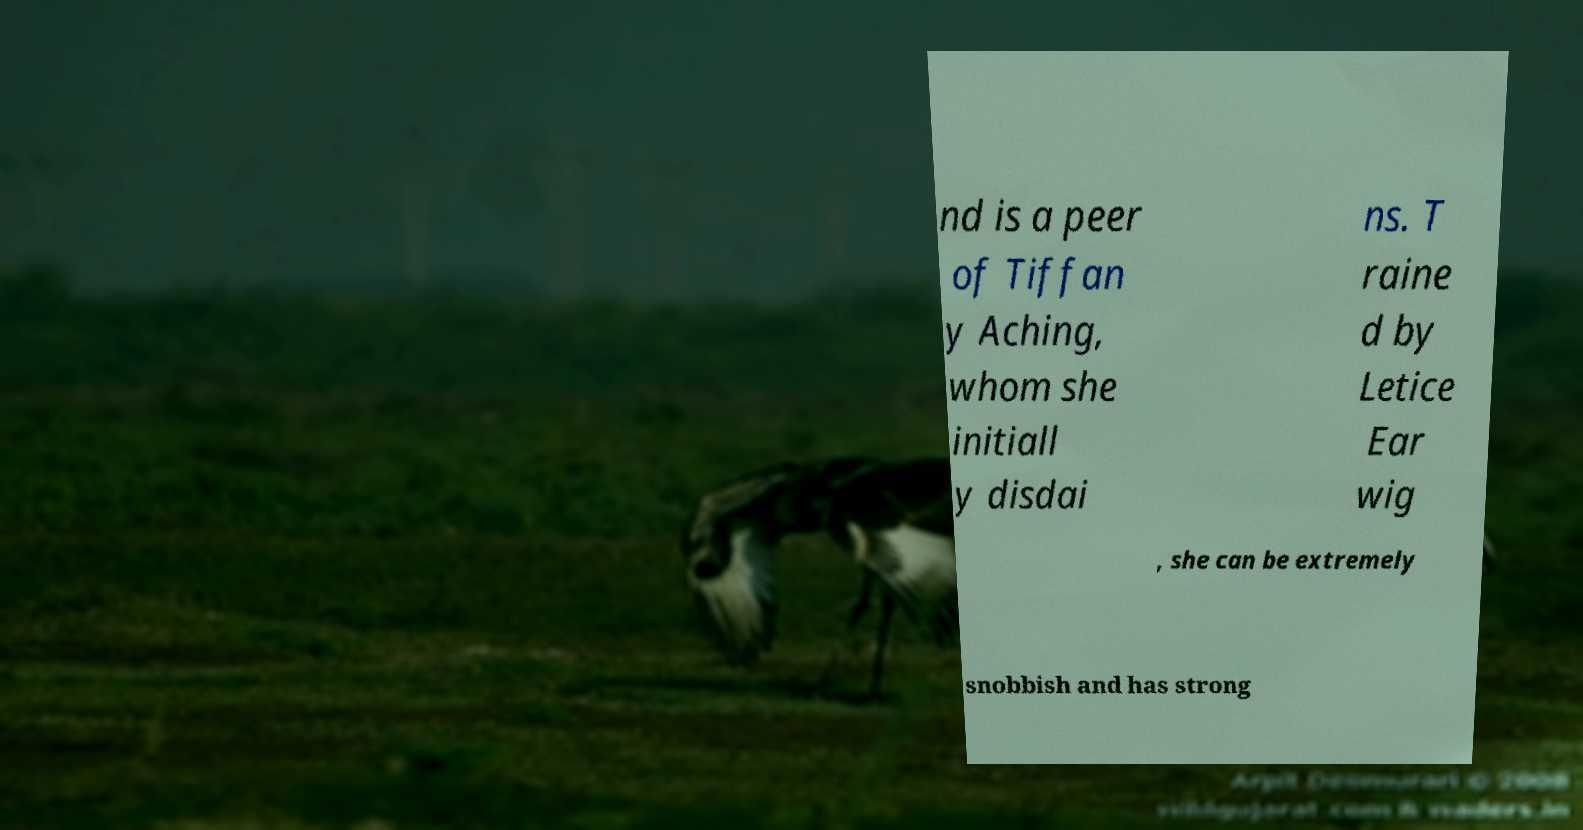Could you assist in decoding the text presented in this image and type it out clearly? nd is a peer of Tiffan y Aching, whom she initiall y disdai ns. T raine d by Letice Ear wig , she can be extremely snobbish and has strong 